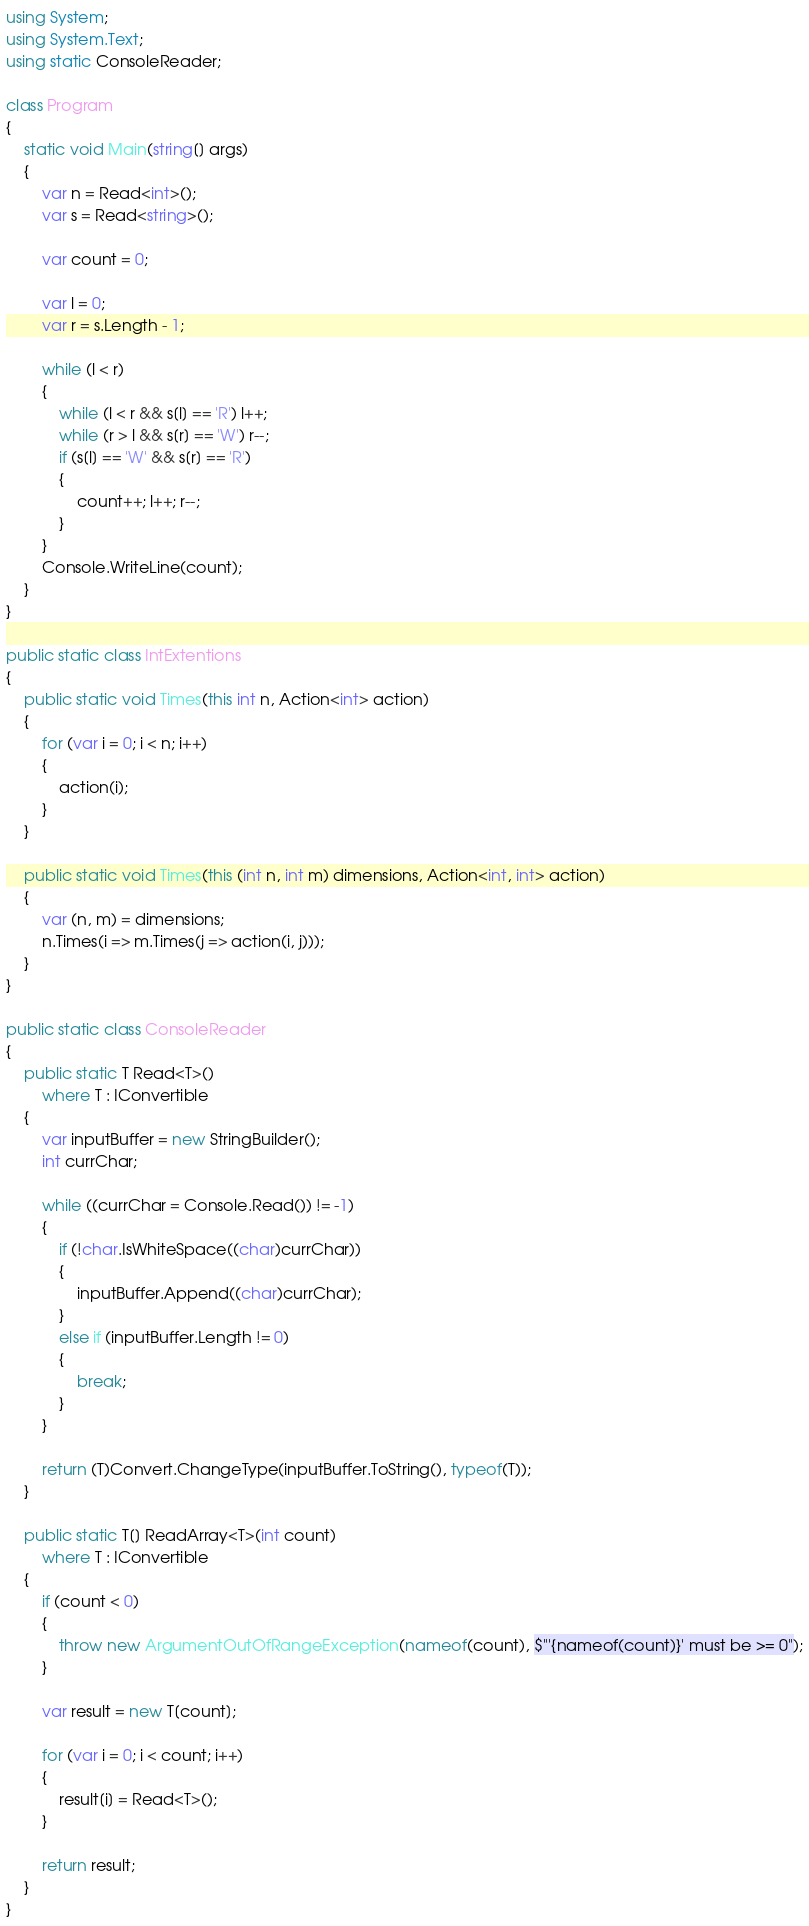Convert code to text. <code><loc_0><loc_0><loc_500><loc_500><_C#_>using System;
using System.Text;
using static ConsoleReader;

class Program
{
    static void Main(string[] args)
    {
        var n = Read<int>();
        var s = Read<string>();

        var count = 0;

        var l = 0;
        var r = s.Length - 1;

        while (l < r)
        {
            while (l < r && s[l] == 'R') l++;
            while (r > l && s[r] == 'W') r--;
            if (s[l] == 'W' && s[r] == 'R')
            {
                count++; l++; r--;
            }
        }
        Console.WriteLine(count);
    }
}

public static class IntExtentions
{
    public static void Times(this int n, Action<int> action)
    {
        for (var i = 0; i < n; i++)
        {
            action(i);
        }
    }

    public static void Times(this (int n, int m) dimensions, Action<int, int> action)
    {
        var (n, m) = dimensions;
        n.Times(i => m.Times(j => action(i, j)));
    }
}

public static class ConsoleReader
{
    public static T Read<T>()
        where T : IConvertible
    {
        var inputBuffer = new StringBuilder();
        int currChar;

        while ((currChar = Console.Read()) != -1)
        {
            if (!char.IsWhiteSpace((char)currChar))
            {
                inputBuffer.Append((char)currChar);
            }
            else if (inputBuffer.Length != 0)
            {
                break;
            }
        }

        return (T)Convert.ChangeType(inputBuffer.ToString(), typeof(T));
    }

    public static T[] ReadArray<T>(int count)
        where T : IConvertible
    {
        if (count < 0)
        {
            throw new ArgumentOutOfRangeException(nameof(count), $"'{nameof(count)}' must be >= 0");
        }

        var result = new T[count];

        for (var i = 0; i < count; i++)
        {
            result[i] = Read<T>();
        }

        return result;
    }
}</code> 